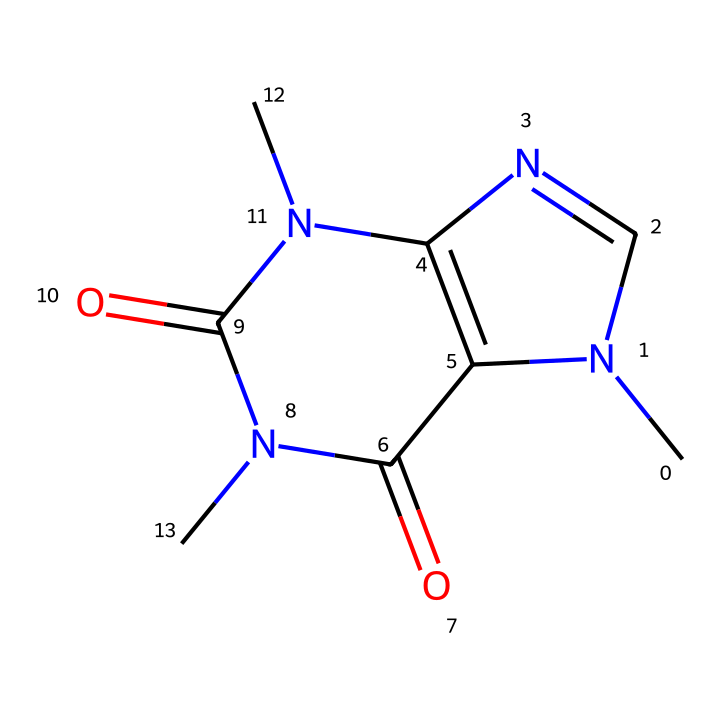What is the total number of nitrogen atoms in this chemical? By analyzing the structure, we identify the atoms present, particularly focusing on nitrogen. There are two distinct nitrogen atoms present in the molecule, which can be counted in the SMILES representation.
Answer: two How many carbon atoms does this caffeine molecule contain? In the chemical structure, carbon atoms can be counted by visually identifying each carbon within the SMILES representation. There are eight carbon atoms in total in the caffeine structure.
Answer: eight What functional groups are present in caffeine? The structure includes carbonyl (C=O) groups and nitrogen-containing groups, mainly represented by amines and amides. The inclusion of these functional groups indicates that caffeine is an alkaloid, impacting its psychoactive properties.
Answer: carbonyl and nitrogen How does caffeine affect cognitive function? Caffeine works as a central nervous system stimulant, blocking adenosine receptors which in turn increases alertness, attention, and overall cognitive function, facilitating better communication and response time.
Answer: stimulates Is caffeine classified as a coordination compound? Caffeine does not form coordination complexes characterized by coordination bonds between metal ions and ligands. Instead, it consists primarily of organic molecules without a central metal ion.
Answer: no Which specific molecular feature allows caffeine to penetrate the blood-brain barrier? The structure includes nitrogen atoms that make caffeine a lipid-soluble molecule, allowing it to efficiently cross the blood-brain barrier and exert its effects on brain function.
Answer: nitrogen 